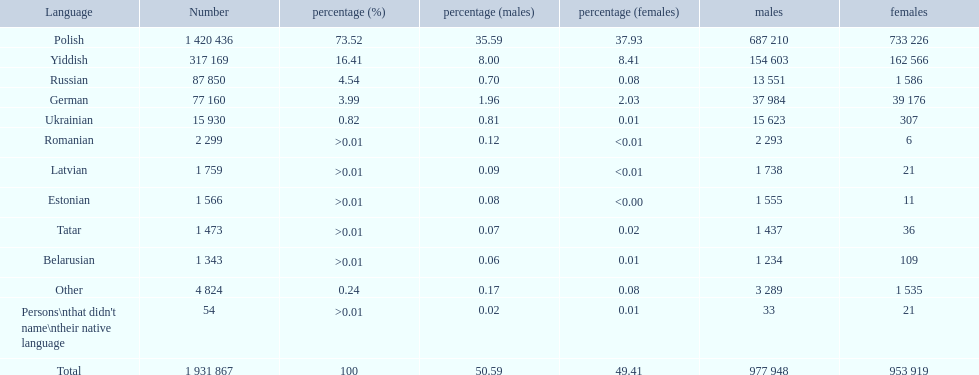What named native languages spoken in the warsaw governorate have more males then females? Russian, Ukrainian, Romanian, Latvian, Estonian, Tatar, Belarusian. Which of those have less then 500 males listed? Romanian, Latvian, Estonian, Tatar, Belarusian. Of the remaining languages which of them have less then 20 females? Romanian, Estonian. Which of these has the highest total number listed? Romanian. 